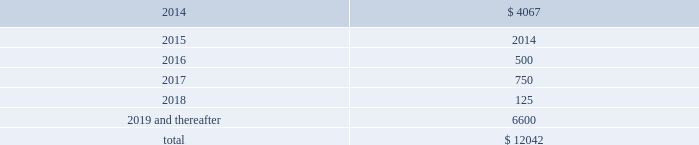Devon energy corporation and subsidiaries notes to consolidated financial statements 2013 ( continued ) debt maturities as of december 31 , 2013 , excluding premiums and discounts , are as follows ( in millions ) : .
Credit lines devon has a $ 3.0 billion syndicated , unsecured revolving line of credit ( the 201csenior credit facility 201d ) that matures on october 24 , 2018 .
However , prior to the maturity date , devon has the option to extend the maturity for up to one additional one-year period , subject to the approval of the lenders .
Amounts borrowed under the senior credit facility may , at the election of devon , bear interest at various fixed rate options for periods of up to twelve months .
Such rates are generally less than the prime rate .
However , devon may elect to borrow at the prime rate .
The senior credit facility currently provides for an annual facility fee of $ 3.8 million that is payable quarterly in arrears .
As of december 31 , 2013 , there were no borrowings under the senior credit facility .
The senior credit facility contains only one material financial covenant .
This covenant requires devon 2019s ratio of total funded debt to total capitalization , as defined in the credit agreement , to be no greater than 65 percent .
The credit agreement contains definitions of total funded debt and total capitalization that include adjustments to the respective amounts reported in the accompanying financial statements .
Also , total capitalization is adjusted to add back noncash financial write-downs such as full cost ceiling impairments or goodwill impairments .
As of december 31 , 2013 , devon was in compliance with this covenant with a debt-to- capitalization ratio of 25.7 percent .
Commercial paper devon has access to $ 3.0 billion of short-term credit under its commercial paper program .
Commercial paper debt generally has a maturity of between 1 and 90 days , although it can have a maturity of up to 365 days , and bears interest at rates agreed to at the time of the borrowing .
The interest rate is generally based on a standard index such as the federal funds rate , libor , or the money market rate as found in the commercial paper market .
As of december 31 , 2013 , devon 2019s weighted average borrowing rate on its commercial paper borrowings was 0.30 percent .
Other debentures and notes following are descriptions of the various other debentures and notes outstanding at december 31 , 2013 , as listed in the table presented at the beginning of this note .
Geosouthern debt in december 2013 , in conjunction with the planned geosouthern acquisition , devon issued $ 2.25 billion aggregate principal amount of fixed and floating rate senior notes resulting in cash proceeds of approximately .
As of december 31 , 2013 what was the percent of the devons debt maturities due in 2014? 
Computations: (4067 / 12042)
Answer: 0.33773. 